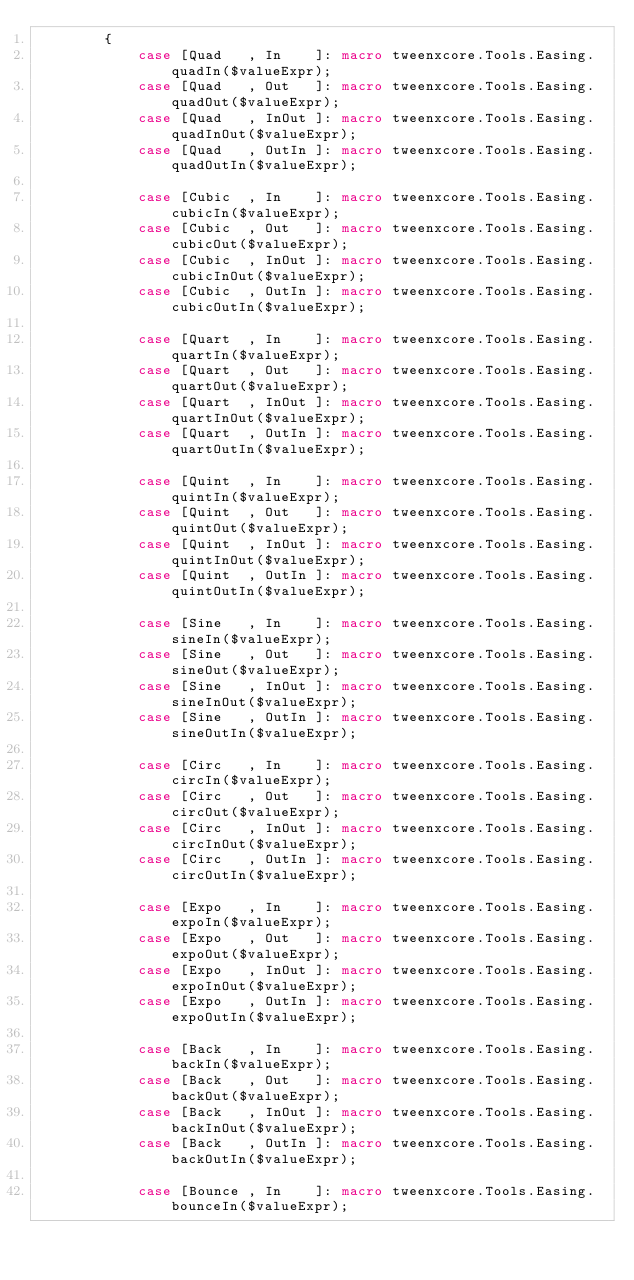<code> <loc_0><loc_0><loc_500><loc_500><_Haxe_>        {
            case [Quad   , In    ]: macro tweenxcore.Tools.Easing.quadIn($valueExpr);
            case [Quad   , Out   ]: macro tweenxcore.Tools.Easing.quadOut($valueExpr);
            case [Quad   , InOut ]: macro tweenxcore.Tools.Easing.quadInOut($valueExpr);
            case [Quad   , OutIn ]: macro tweenxcore.Tools.Easing.quadOutIn($valueExpr);
            
            case [Cubic  , In    ]: macro tweenxcore.Tools.Easing.cubicIn($valueExpr);
            case [Cubic  , Out   ]: macro tweenxcore.Tools.Easing.cubicOut($valueExpr);
            case [Cubic  , InOut ]: macro tweenxcore.Tools.Easing.cubicInOut($valueExpr);
            case [Cubic  , OutIn ]: macro tweenxcore.Tools.Easing.cubicOutIn($valueExpr);
            
            case [Quart  , In    ]: macro tweenxcore.Tools.Easing.quartIn($valueExpr);
            case [Quart  , Out   ]: macro tweenxcore.Tools.Easing.quartOut($valueExpr);
            case [Quart  , InOut ]: macro tweenxcore.Tools.Easing.quartInOut($valueExpr);
            case [Quart  , OutIn ]: macro tweenxcore.Tools.Easing.quartOutIn($valueExpr);
            
            case [Quint  , In    ]: macro tweenxcore.Tools.Easing.quintIn($valueExpr);
            case [Quint  , Out   ]: macro tweenxcore.Tools.Easing.quintOut($valueExpr);
            case [Quint  , InOut ]: macro tweenxcore.Tools.Easing.quintInOut($valueExpr);
            case [Quint  , OutIn ]: macro tweenxcore.Tools.Easing.quintOutIn($valueExpr);
            
            case [Sine   , In    ]: macro tweenxcore.Tools.Easing.sineIn($valueExpr);
            case [Sine   , Out   ]: macro tweenxcore.Tools.Easing.sineOut($valueExpr);
            case [Sine   , InOut ]: macro tweenxcore.Tools.Easing.sineInOut($valueExpr);
            case [Sine   , OutIn ]: macro tweenxcore.Tools.Easing.sineOutIn($valueExpr);
            
            case [Circ   , In    ]: macro tweenxcore.Tools.Easing.circIn($valueExpr);
            case [Circ   , Out   ]: macro tweenxcore.Tools.Easing.circOut($valueExpr);
            case [Circ   , InOut ]: macro tweenxcore.Tools.Easing.circInOut($valueExpr);
            case [Circ   , OutIn ]: macro tweenxcore.Tools.Easing.circOutIn($valueExpr);
            
            case [Expo   , In    ]: macro tweenxcore.Tools.Easing.expoIn($valueExpr);
            case [Expo   , Out   ]: macro tweenxcore.Tools.Easing.expoOut($valueExpr);
            case [Expo   , InOut ]: macro tweenxcore.Tools.Easing.expoInOut($valueExpr);
            case [Expo   , OutIn ]: macro tweenxcore.Tools.Easing.expoOutIn($valueExpr);
            
            case [Back   , In    ]: macro tweenxcore.Tools.Easing.backIn($valueExpr);
            case [Back   , Out   ]: macro tweenxcore.Tools.Easing.backOut($valueExpr);
            case [Back   , InOut ]: macro tweenxcore.Tools.Easing.backInOut($valueExpr);
            case [Back   , OutIn ]: macro tweenxcore.Tools.Easing.backOutIn($valueExpr);
            
            case [Bounce , In    ]: macro tweenxcore.Tools.Easing.bounceIn($valueExpr);</code> 